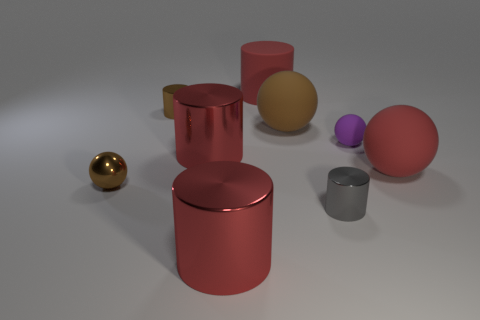How many other things are there of the same shape as the large brown thing? In the image, there are three other objects sharing the cylindrical shape with the large brown one. Each object has distinct colors that differentiate them, yet their geometric similarity is clear. 